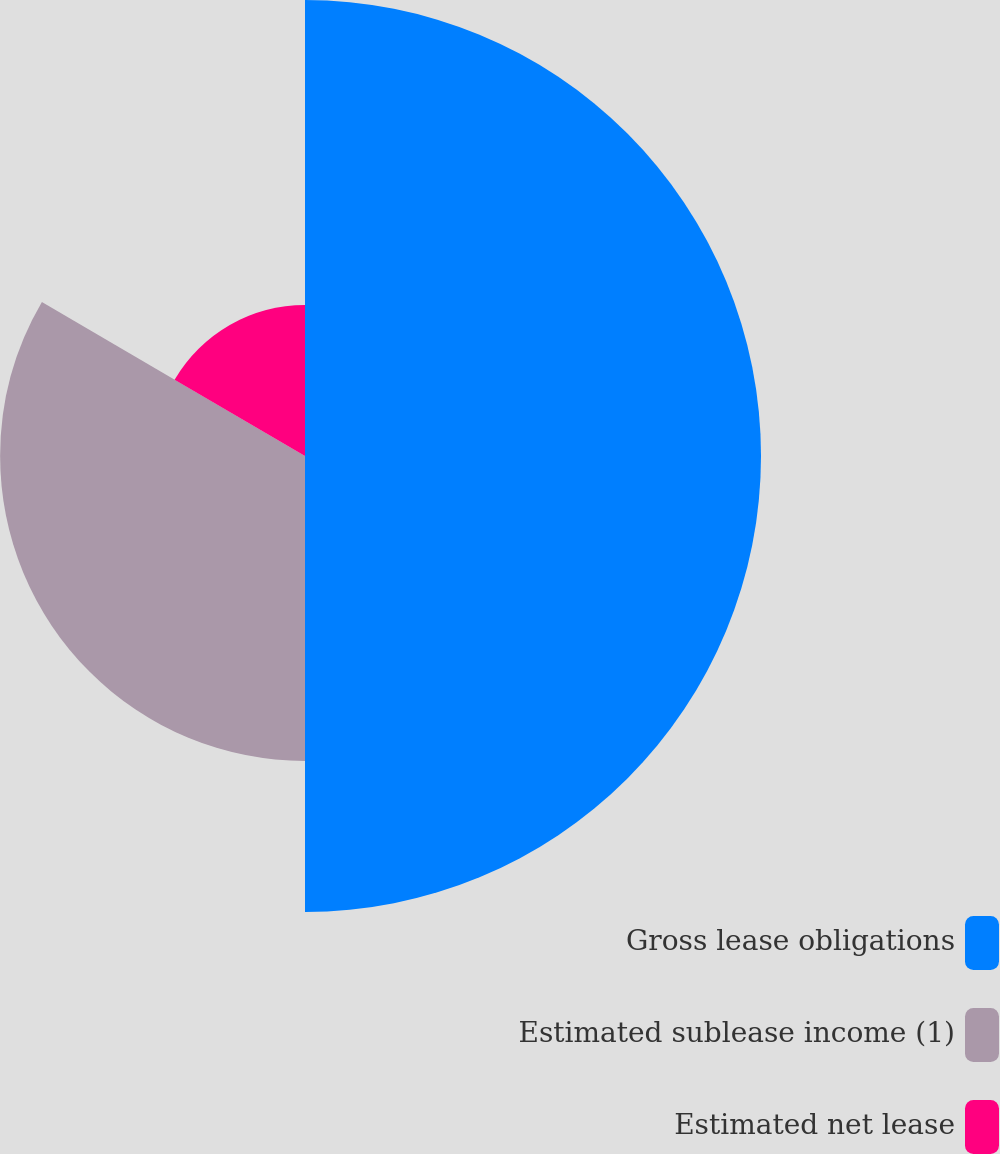Convert chart to OTSL. <chart><loc_0><loc_0><loc_500><loc_500><pie_chart><fcel>Gross lease obligations<fcel>Estimated sublease income (1)<fcel>Estimated net lease<nl><fcel>50.0%<fcel>33.43%<fcel>16.57%<nl></chart> 